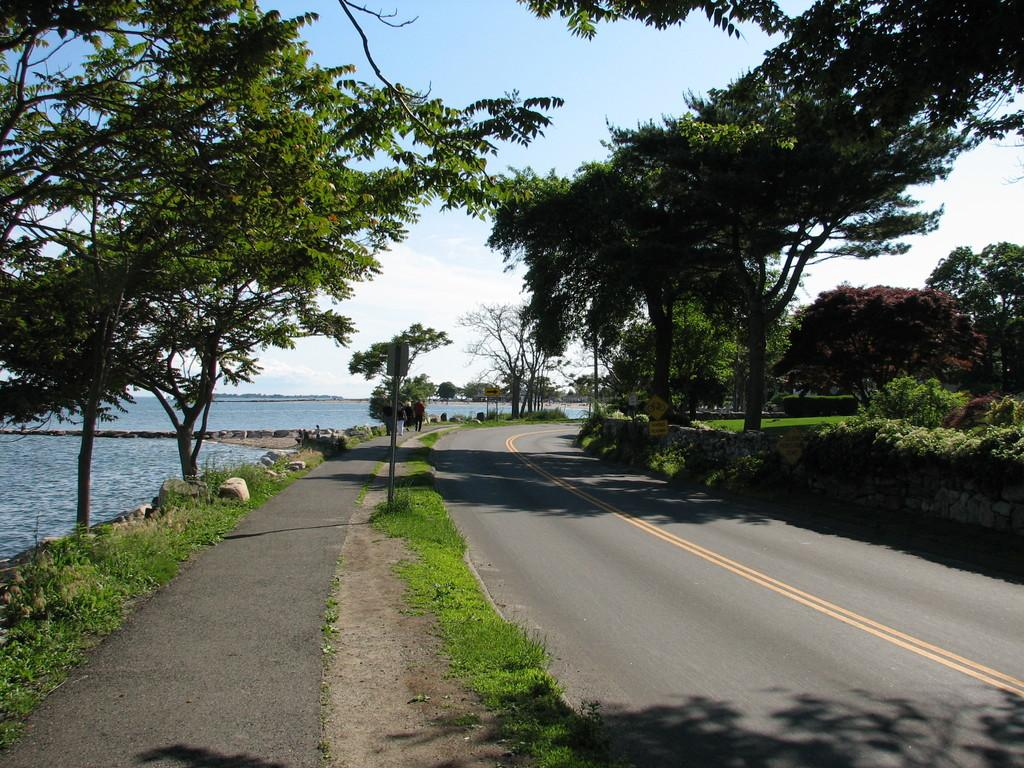What is the main feature of the image? There is a road in the image. What can be seen on the road? There are yellow lines on the road. What type of vegetation is present in the image? There is grass, trees, and water visible in the image. What else can be seen in the image? There is a pole, sky, and stones visible in the image. Can you see a rose growing in the grass in the image? There is no rose visible in the image; only grass, trees, and water are present. Is there a cap on the pole in the image? There is no cap visible on the pole in the image. 